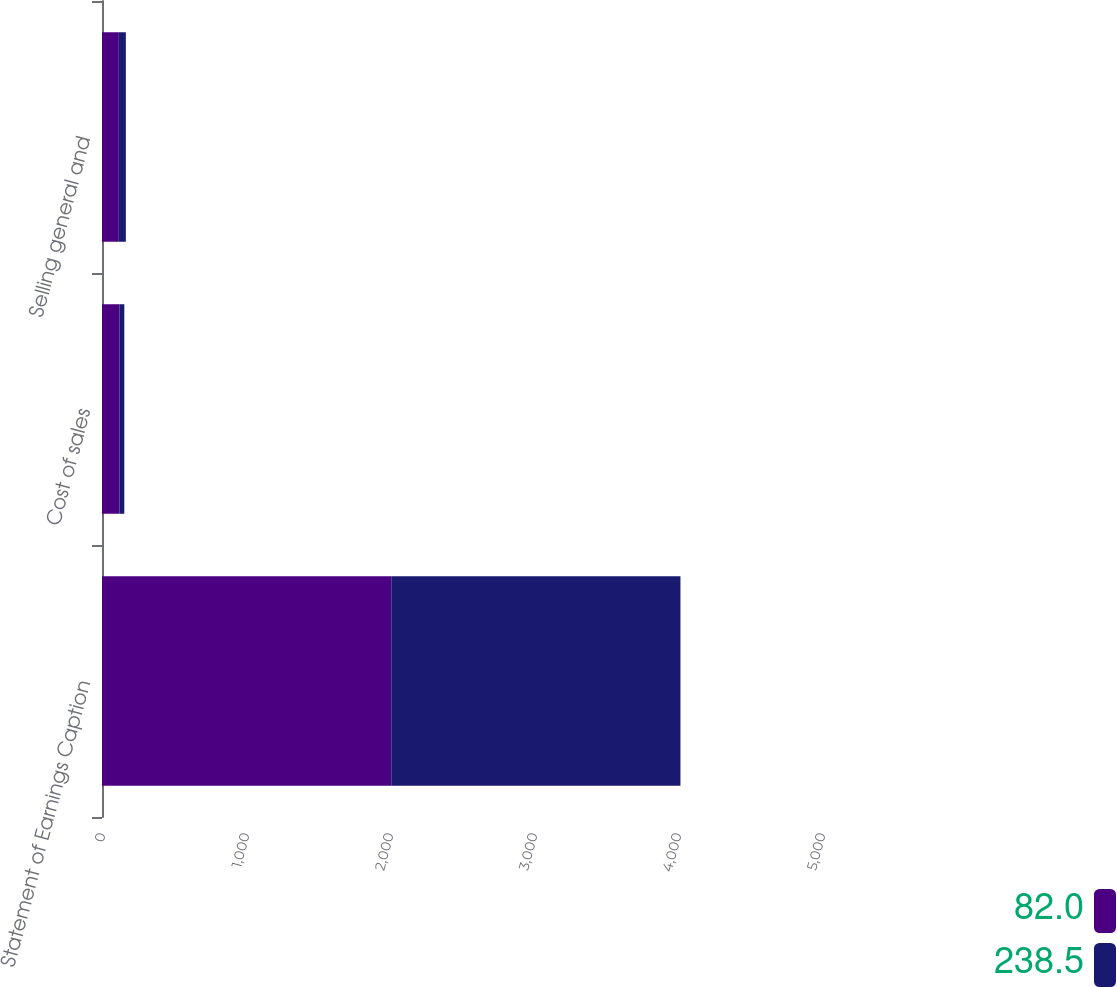Convert chart. <chart><loc_0><loc_0><loc_500><loc_500><stacked_bar_chart><ecel><fcel>Statement of Earnings Caption<fcel>Cost of sales<fcel>Selling general and<nl><fcel>82<fcel>2009<fcel>121.8<fcel>116.7<nl><fcel>238.5<fcel>2008<fcel>33.1<fcel>48.9<nl></chart> 